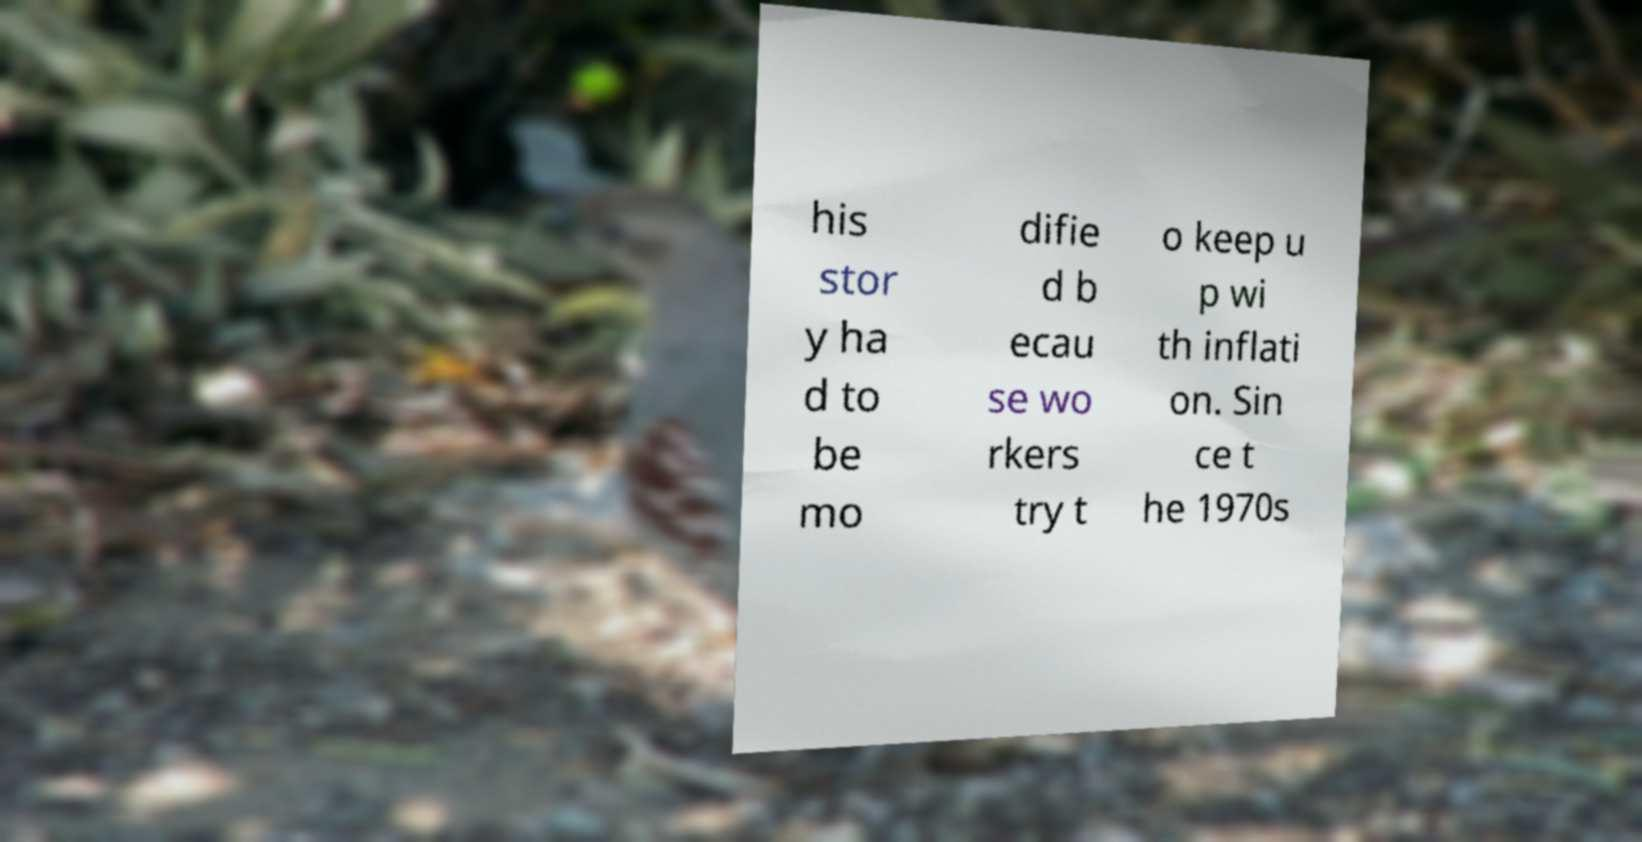There's text embedded in this image that I need extracted. Can you transcribe it verbatim? his stor y ha d to be mo difie d b ecau se wo rkers try t o keep u p wi th inflati on. Sin ce t he 1970s 